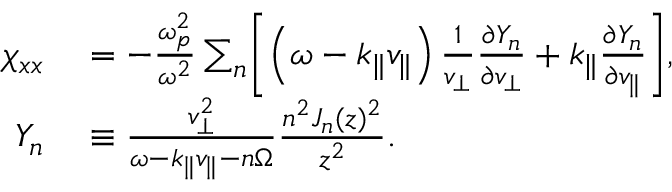<formula> <loc_0><loc_0><loc_500><loc_500>\begin{array} { r l } { \chi _ { x x } } & = - \frac { \omega _ { p } ^ { 2 } } { \omega ^ { 2 } } \sum _ { n } \left [ \left ( \omega - k _ { \| } v _ { \| } \right ) \frac { 1 } { v _ { \perp } } \frac { \partial Y _ { n } } { \partial v _ { \perp } } + k _ { \| } \frac { \partial Y _ { n } } { \partial v _ { \| } } \right ] , } \\ { Y _ { n } } & \equiv \frac { v _ { \perp } ^ { 2 } } { \omega - k _ { \| } v _ { \| } - n \Omega } \frac { n ^ { 2 } J _ { n } ( z ) ^ { 2 } } { z ^ { 2 } } . } \end{array}</formula> 